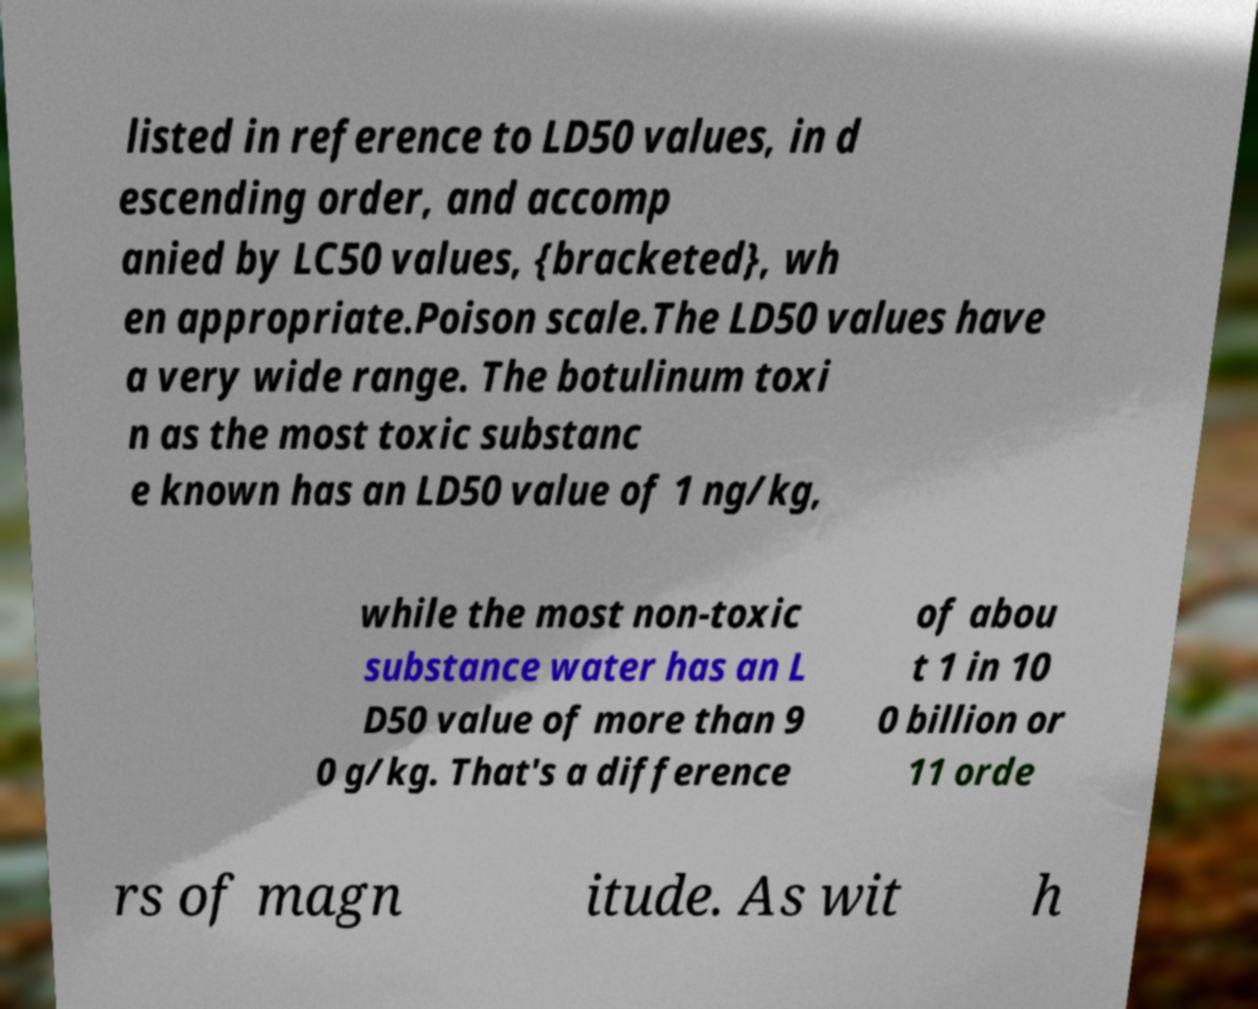What messages or text are displayed in this image? I need them in a readable, typed format. listed in reference to LD50 values, in d escending order, and accomp anied by LC50 values, {bracketed}, wh en appropriate.Poison scale.The LD50 values have a very wide range. The botulinum toxi n as the most toxic substanc e known has an LD50 value of 1 ng/kg, while the most non-toxic substance water has an L D50 value of more than 9 0 g/kg. That's a difference of abou t 1 in 10 0 billion or 11 orde rs of magn itude. As wit h 